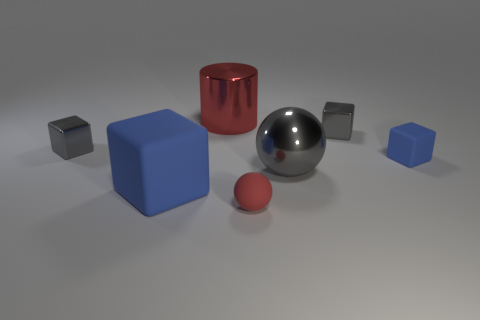How is the lighting affecting the appearance of the objects? The lighting creates soft shadows and highlights that give the objects a three-dimensional appearance. The reflective surfaces, like the silver sphere and the red cylinder, show notable highlights and reflections that enhance their shiny texture. 